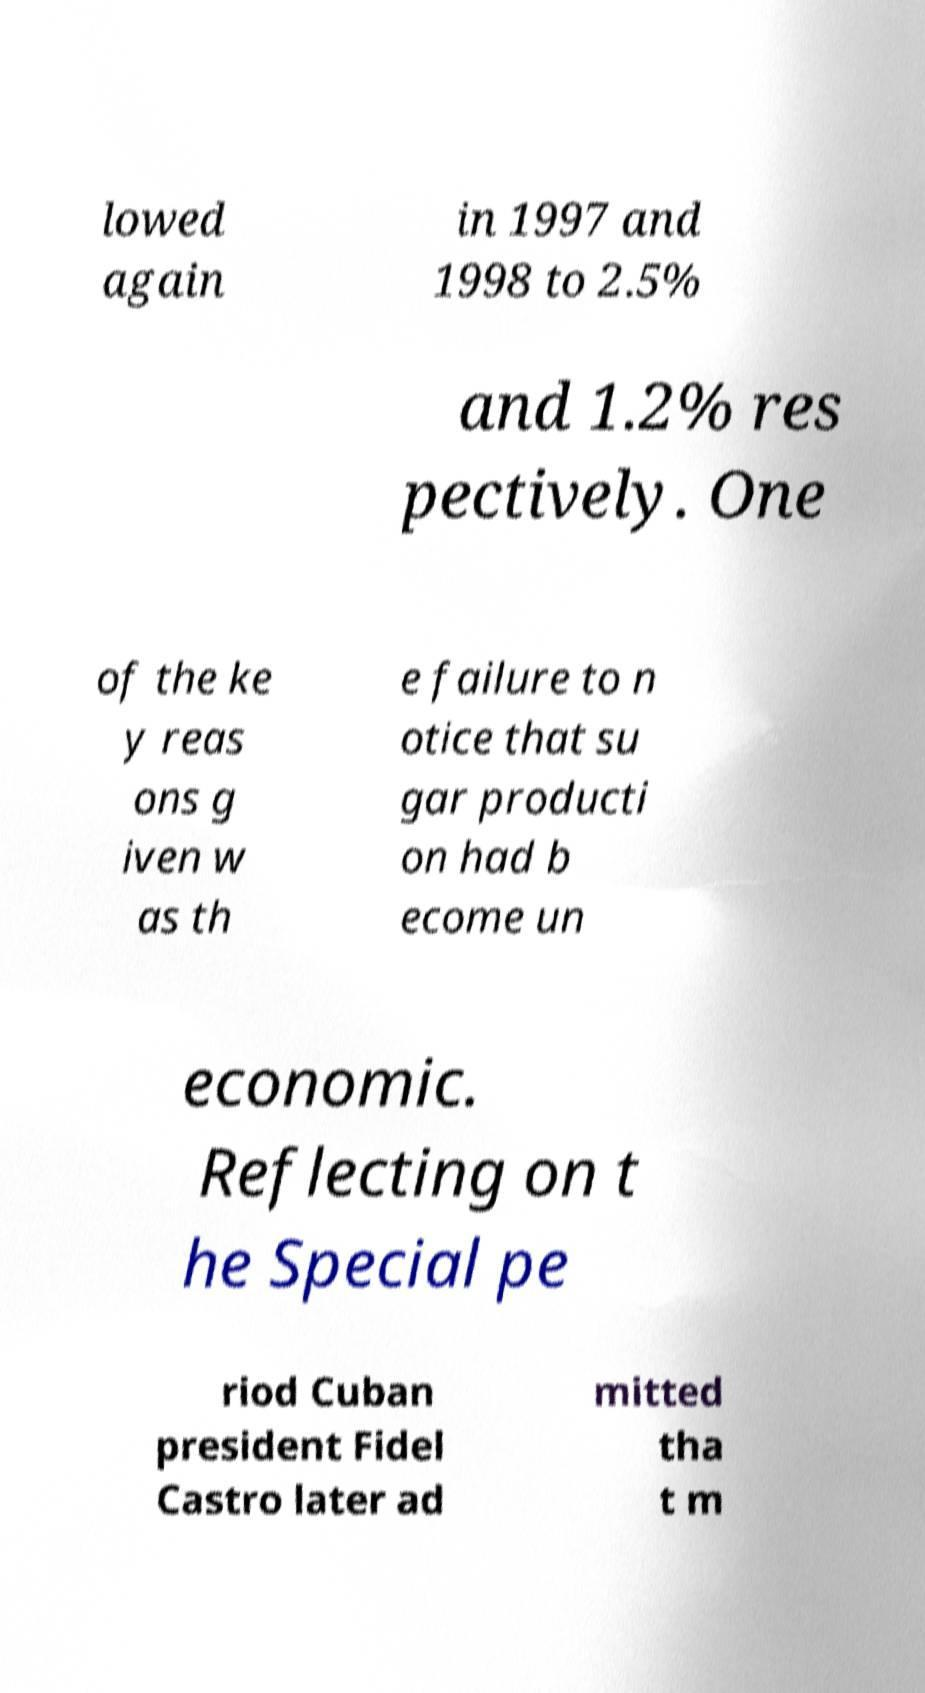Please identify and transcribe the text found in this image. lowed again in 1997 and 1998 to 2.5% and 1.2% res pectively. One of the ke y reas ons g iven w as th e failure to n otice that su gar producti on had b ecome un economic. Reflecting on t he Special pe riod Cuban president Fidel Castro later ad mitted tha t m 